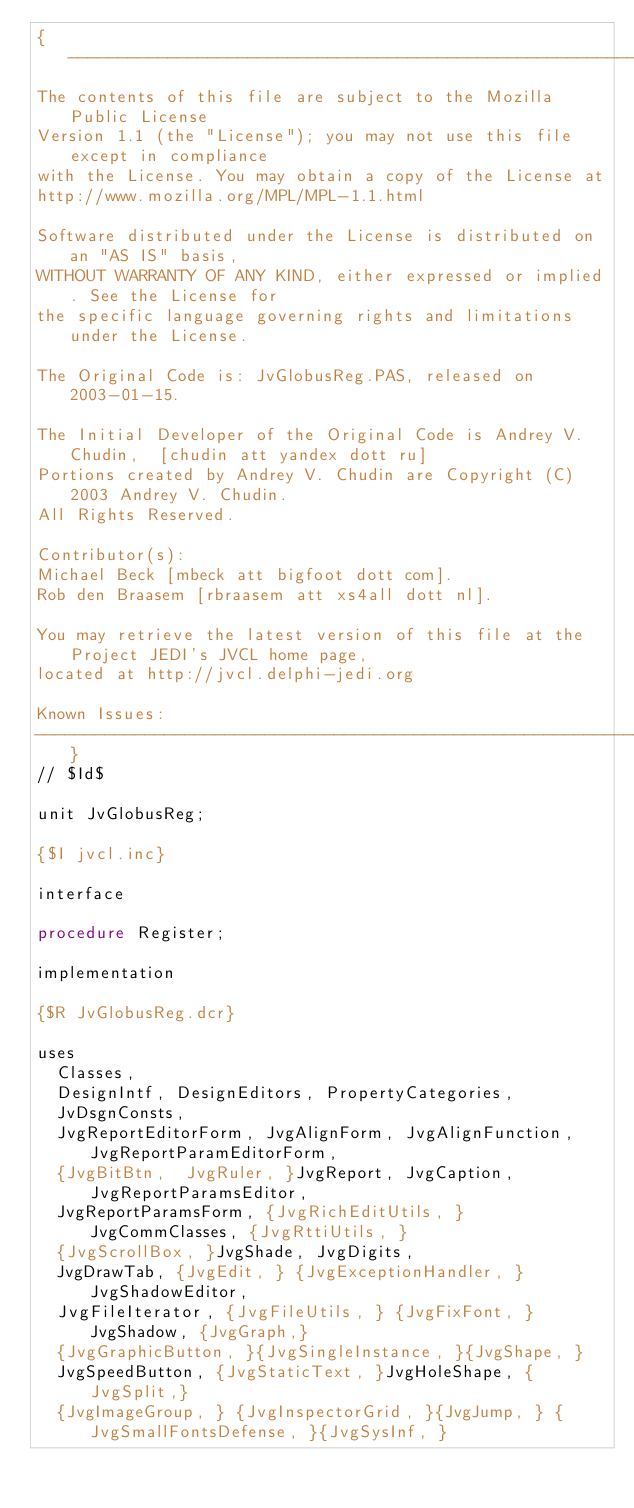Convert code to text. <code><loc_0><loc_0><loc_500><loc_500><_Pascal_>{-----------------------------------------------------------------------------
The contents of this file are subject to the Mozilla Public License
Version 1.1 (the "License"); you may not use this file except in compliance
with the License. You may obtain a copy of the License at
http://www.mozilla.org/MPL/MPL-1.1.html

Software distributed under the License is distributed on an "AS IS" basis,
WITHOUT WARRANTY OF ANY KIND, either expressed or implied. See the License for
the specific language governing rights and limitations under the License.

The Original Code is: JvGlobusReg.PAS, released on 2003-01-15.

The Initial Developer of the Original Code is Andrey V. Chudin,  [chudin att yandex dott ru]
Portions created by Andrey V. Chudin are Copyright (C) 2003 Andrey V. Chudin.
All Rights Reserved.

Contributor(s):
Michael Beck [mbeck att bigfoot dott com].
Rob den Braasem [rbraasem att xs4all dott nl].

You may retrieve the latest version of this file at the Project JEDI's JVCL home page,
located at http://jvcl.delphi-jedi.org

Known Issues:
-----------------------------------------------------------------------------}
// $Id$

unit JvGlobusReg;

{$I jvcl.inc}

interface

procedure Register;

implementation

{$R JvGlobusReg.dcr}

uses
  Classes,
  DesignIntf, DesignEditors, PropertyCategories,
  JvDsgnConsts,
  JvgReportEditorForm, JvgAlignForm, JvgAlignFunction, JvgReportParamEditorForm,
  {JvgBitBtn,  JvgRuler, }JvgReport, JvgCaption, JvgReportParamsEditor,
  JvgReportParamsForm, {JvgRichEditUtils, } JvgCommClasses, {JvgRttiUtils, }
  {JvgScrollBox, }JvgShade, JvgDigits,
  JvgDrawTab, {JvgEdit, } {JvgExceptionHandler, }JvgShadowEditor,
  JvgFileIterator, {JvgFileUtils, } {JvgFixFont, }JvgShadow, {JvgGraph,}
  {JvgGraphicButton, }{JvgSingleInstance, }{JvgShape, }
  JvgSpeedButton, {JvgStaticText, }JvgHoleShape, {JvgSplit,}
  {JvgImageGroup, } {JvgInspectorGrid, }{JvgJump, } {JvgSmallFontsDefense, }{JvgSysInf, }</code> 